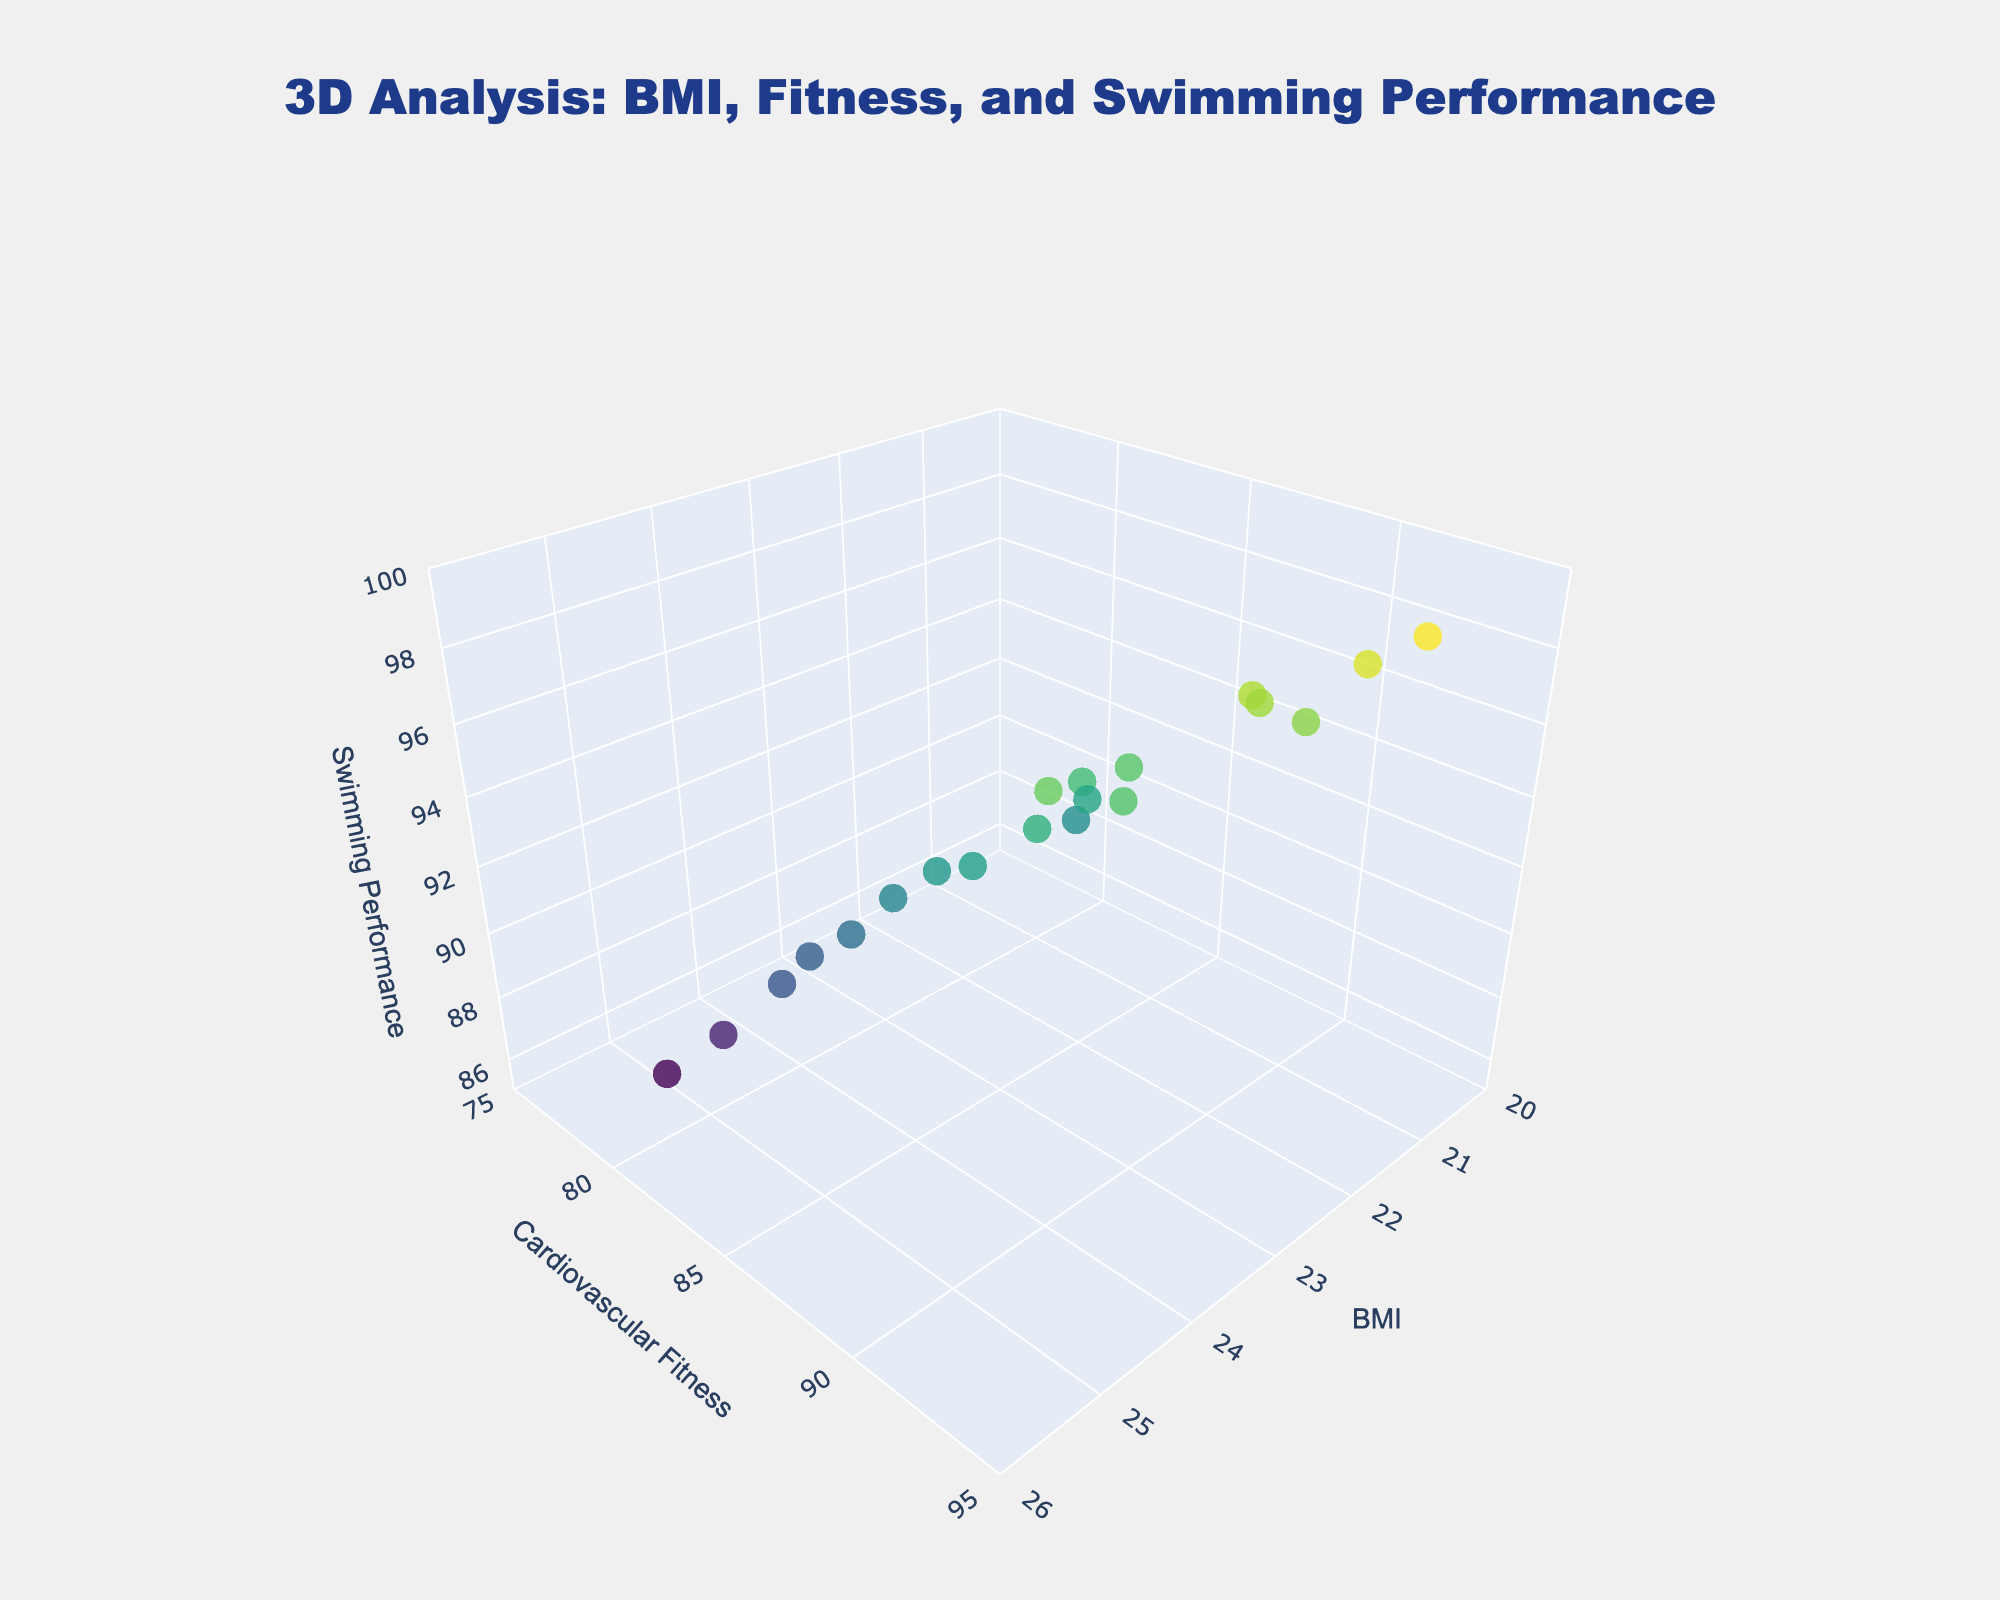What's the title of the figure? The title is text displayed at the top center of the figure, indicating what the plot represents. Here, it reads "3D Analysis: BMI, Fitness, and Swimming Performance".
Answer: 3D Analysis: BMI, Fitness, and Swimming Performance What data is on the x-axis? The x-axis represents BMI (Body Mass Index), as indicated by the label on the horizontal axis.
Answer: BMI How many data points are illustrated in the plot? Each dot in the 3D scatter plot represents a data point. By counting them, we can see there are 20 data points.
Answer: 20 What ranges are covered by the Cardiovascular Fitness axis? The y-axis title, Cardiovascular Fitness, shows ranges from 75 to 95, as observed from the axis limits.
Answer: 75 to 95 What is the highest visible Swimming Performance value in the plot? By looking at the z-axis, which represents Swimming Performance, and identifying the highest data point, the maximum visible value is approximately 98.6.
Answer: 98.6 What is the relationship between BMI and Swimming Performance for the lowest fitness value? Locate the point with the lowest Cardiovascular Fitness (79) and check its BMI (25.2) and Swimming Performance (86.2). Higher BMI does not correlate with higher performance in this case.
Answer: Higher BMI, lower performance What's the average Cardiovascular Fitness value for athletes with a Swimming Performance above 90? First, identify data points where Swimming Performance > 90: 85, 88, 90, 93, 87, 91, 86, 85, 92, 80, 89, 87, 90, 82, 88, 86. Sum these values and divide by the count (16 points) to get the average.
Answer: 86.25 Do athletes with a BMI between 22 and 23 have better Swimming Performance on average? Filter data points with 22 <= BMI <= 23, and calculate the average Swimming Performance for those points (e.g., 92.3, 94.8, 93.5). Compare with the overall average Performance data.
Answer: Averaged close to 93.53 Which data point has the highest Cardiovascular Fitness and what are its BMI and Swimming Performance values? Identify the maximum value on the Cardiovascular Fitness y-axis (93) and find the corresponding BMI (20.9) and Swimming Performance (98.6) values for that data point.
Answer: BMI 20.9, Performance 98.6 What is the trend in Swimming Performance as Cardiovascular Fitness increases? Observe how Swimming Performance values vary with increasing Cardiovascular Fitness along the y-axis, noting if values tend to go up, down, or remain the same. Increasing fitness tends to enhance performance.
Answer: Increasing fitness improves performance 